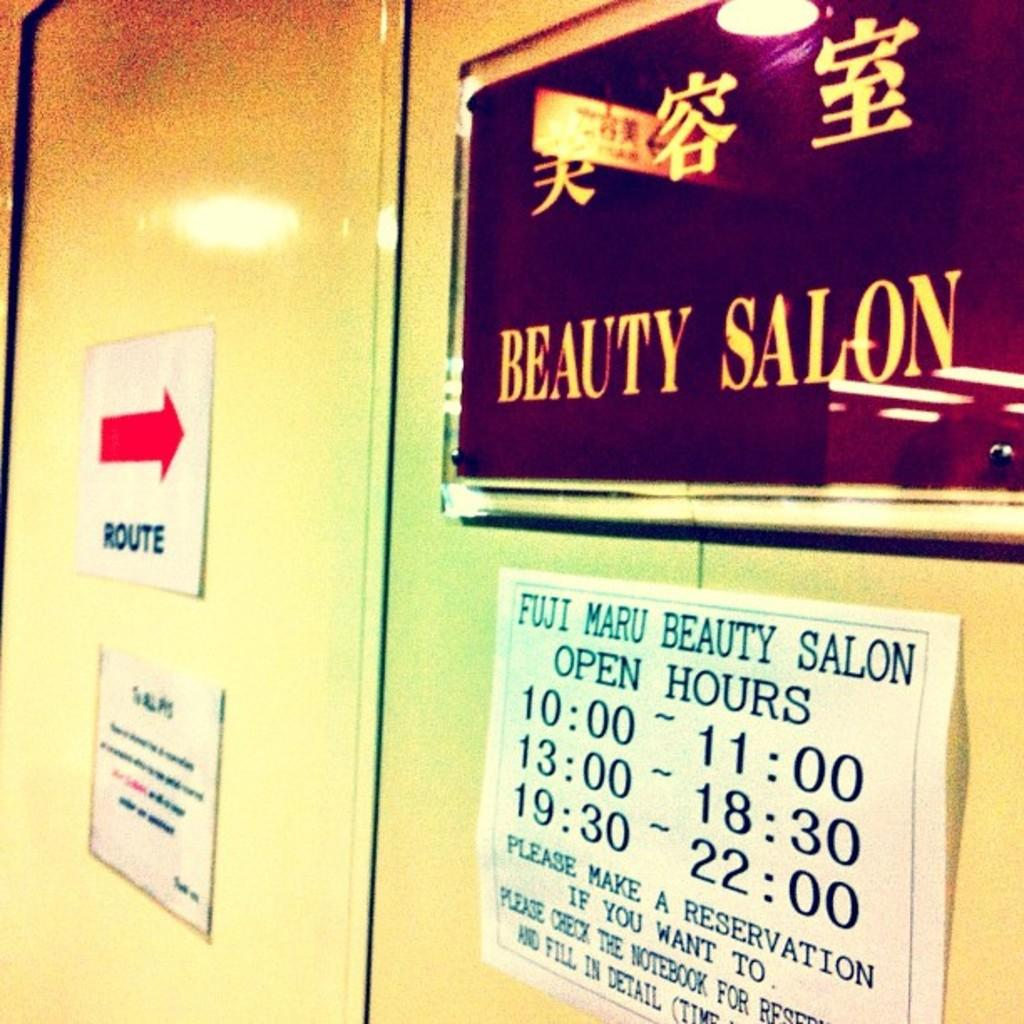<image>
Create a compact narrative representing the image presented. a sign for a Beauty Salon on a door 